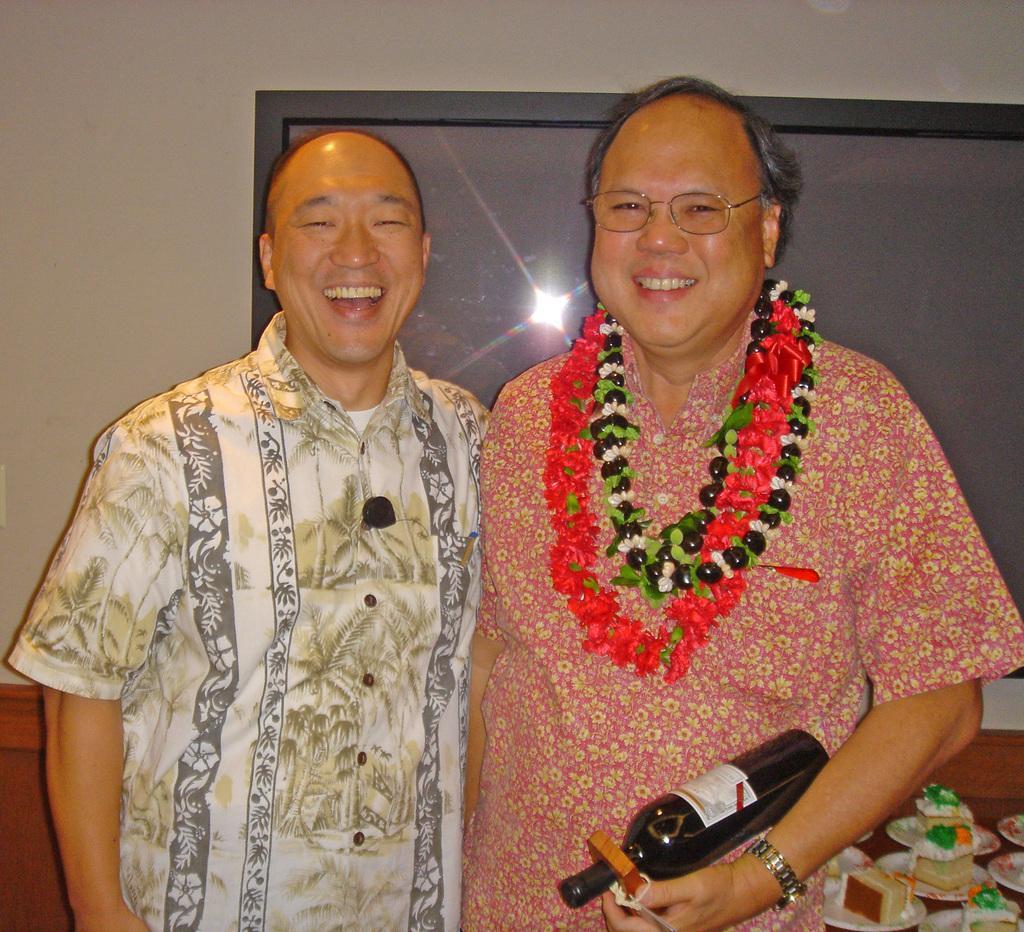Please provide a concise description of this image. In this image we can see two persons standing. On the right side the person is wearing a garland and holding a bottle. At the back side there is cake on a plate. The person is smiling. 